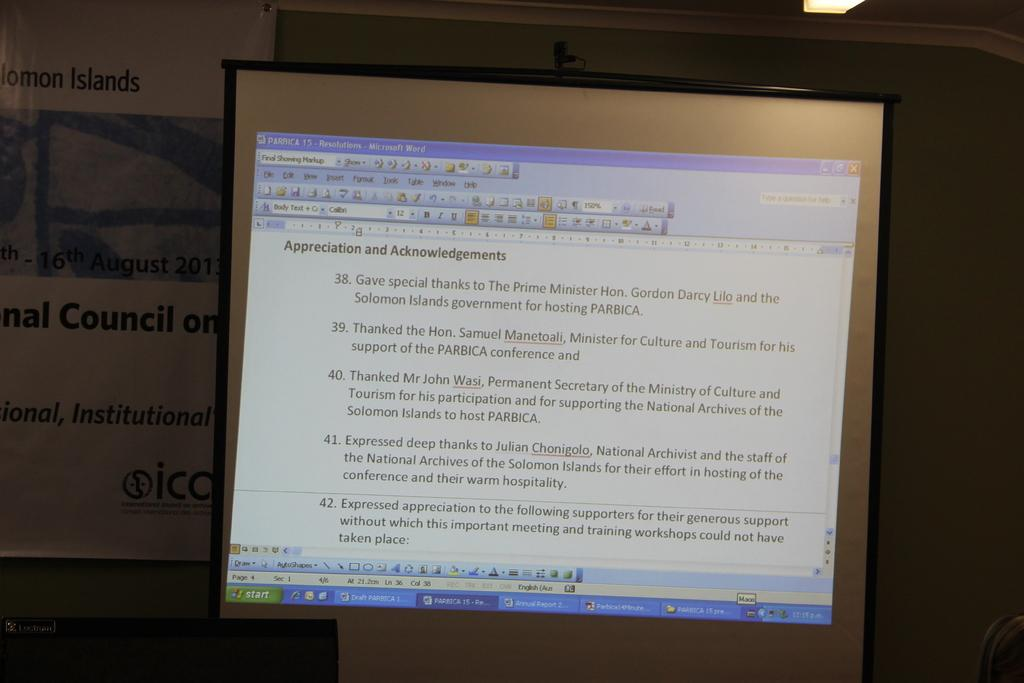<image>
Share a concise interpretation of the image provided. A computer screen showing an appreciation and acknowledgements document. 